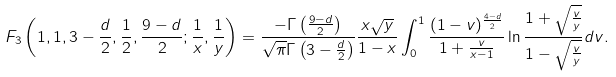Convert formula to latex. <formula><loc_0><loc_0><loc_500><loc_500>F _ { 3 } \left ( 1 , 1 , 3 - \frac { d } { 2 } , \frac { 1 } { 2 } , \frac { 9 - d } { 2 } ; \frac { 1 } { x } , \frac { 1 } { y } \right ) = \frac { - \Gamma \left ( \frac { 9 - d } { 2 } \right ) } { \sqrt { \pi } \Gamma \left ( 3 - \frac { d } { 2 } \right ) } \frac { x \sqrt { y } } { 1 - x } \int _ { 0 } ^ { 1 } \frac { ( 1 - v ) ^ { \frac { 4 - d } { 2 } } } { 1 + \frac { v } { x - 1 } } \ln \frac { 1 + \sqrt { \frac { v } { y } } } { 1 - \sqrt { \frac { v } { y } } } d v .</formula> 